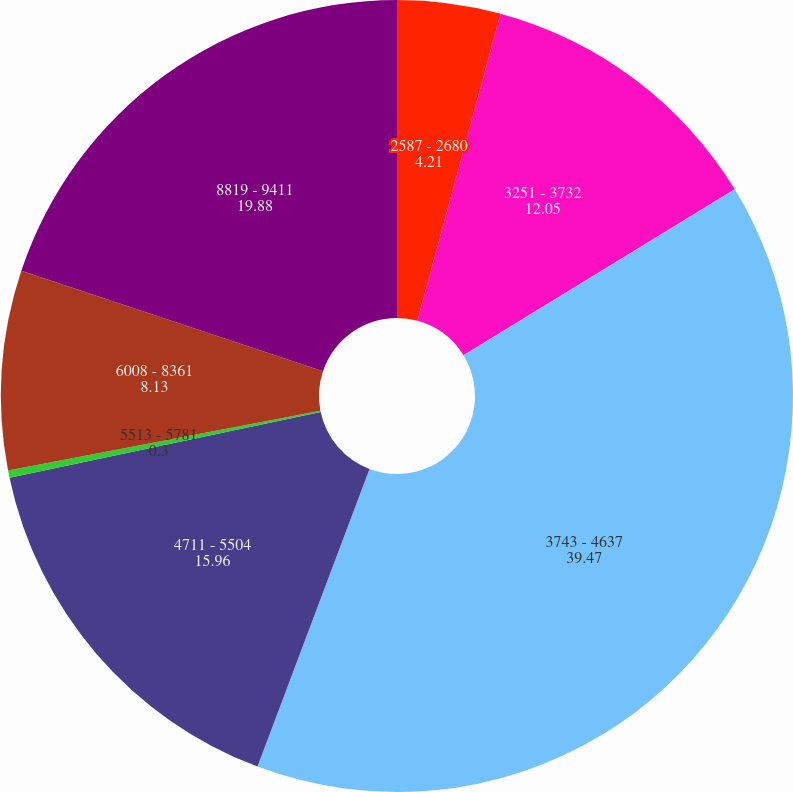Convert chart to OTSL. <chart><loc_0><loc_0><loc_500><loc_500><pie_chart><fcel>2587 - 2680<fcel>3251 - 3732<fcel>3743 - 4637<fcel>4711 - 5504<fcel>5513 - 5781<fcel>6008 - 8361<fcel>8819 - 9411<nl><fcel>4.21%<fcel>12.05%<fcel>39.47%<fcel>15.96%<fcel>0.3%<fcel>8.13%<fcel>19.88%<nl></chart> 